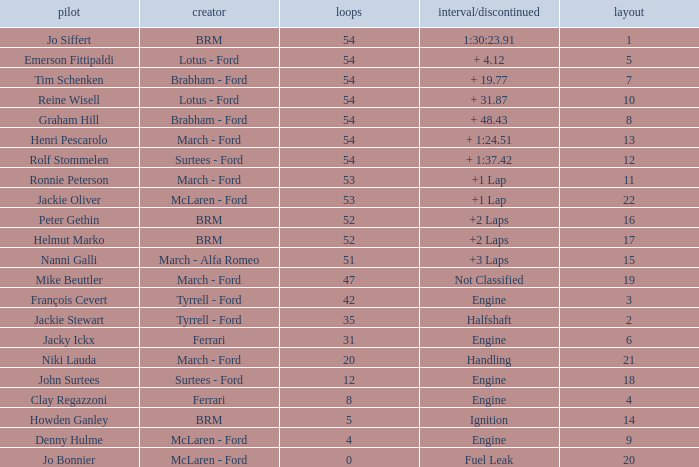How many laps for a grid larger than 1 with a Time/Retired of halfshaft? 35.0. 